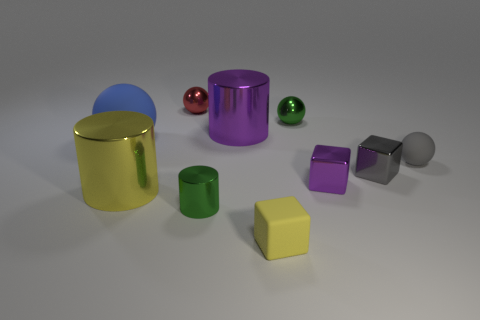Is there any other thing that has the same shape as the gray rubber object? Yes, the gray rubber object appears to be cylindrical in shape. Similarly shaped objects in the image include the purple, blue, and yellow cylinders. 